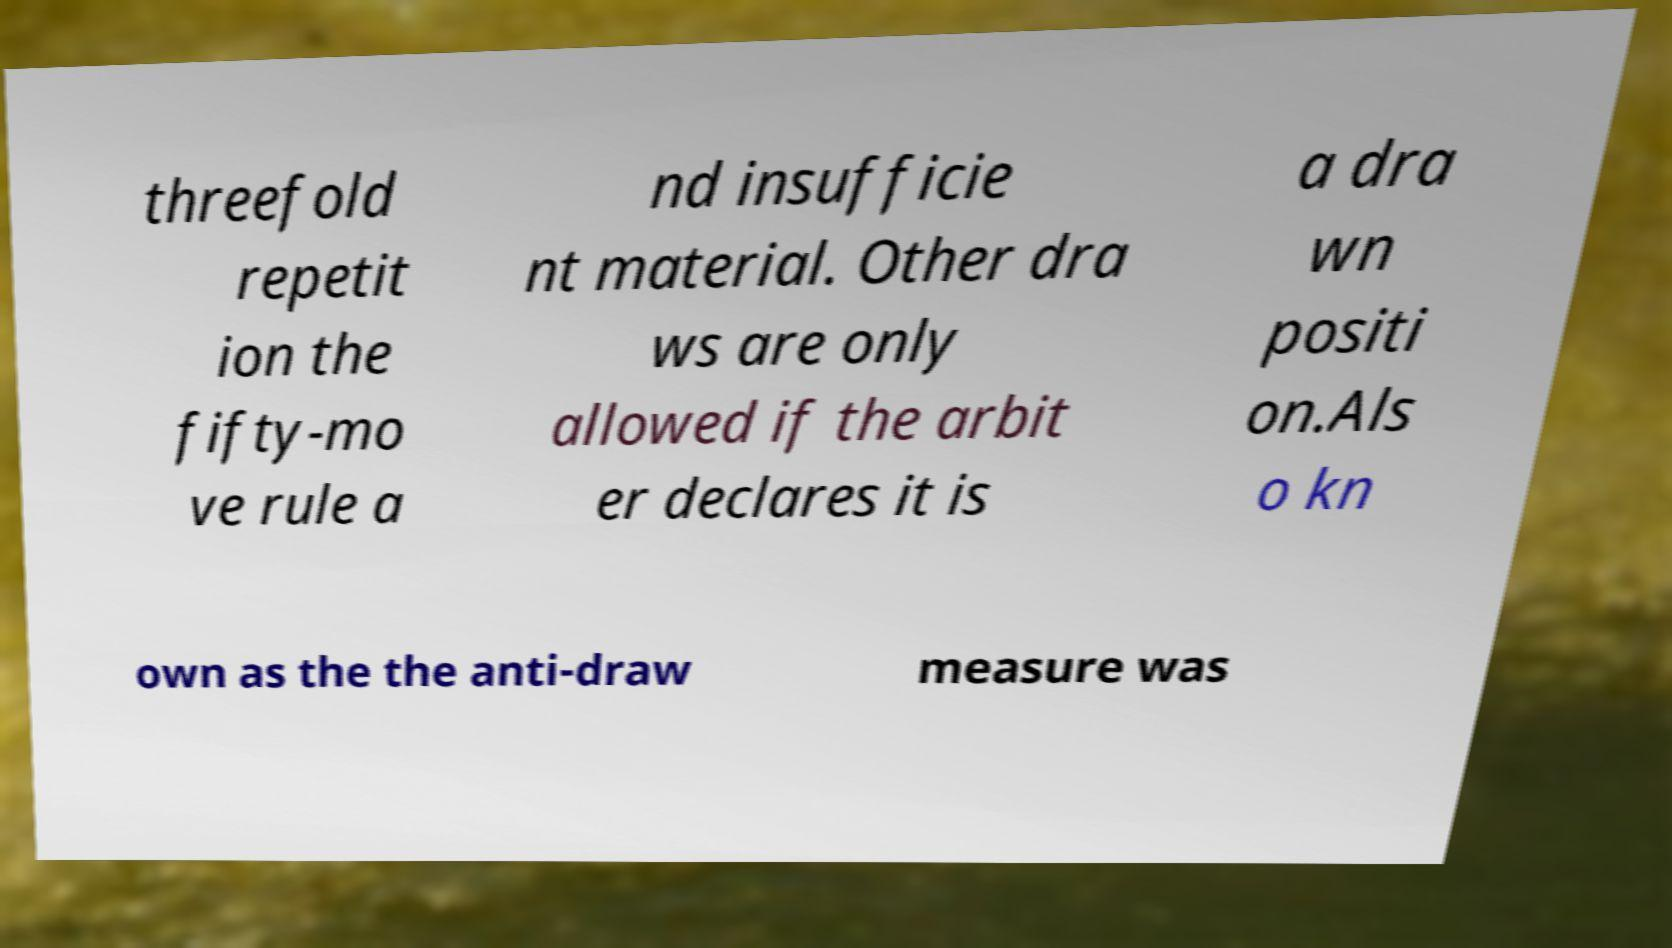I need the written content from this picture converted into text. Can you do that? threefold repetit ion the fifty-mo ve rule a nd insufficie nt material. Other dra ws are only allowed if the arbit er declares it is a dra wn positi on.Als o kn own as the the anti-draw measure was 